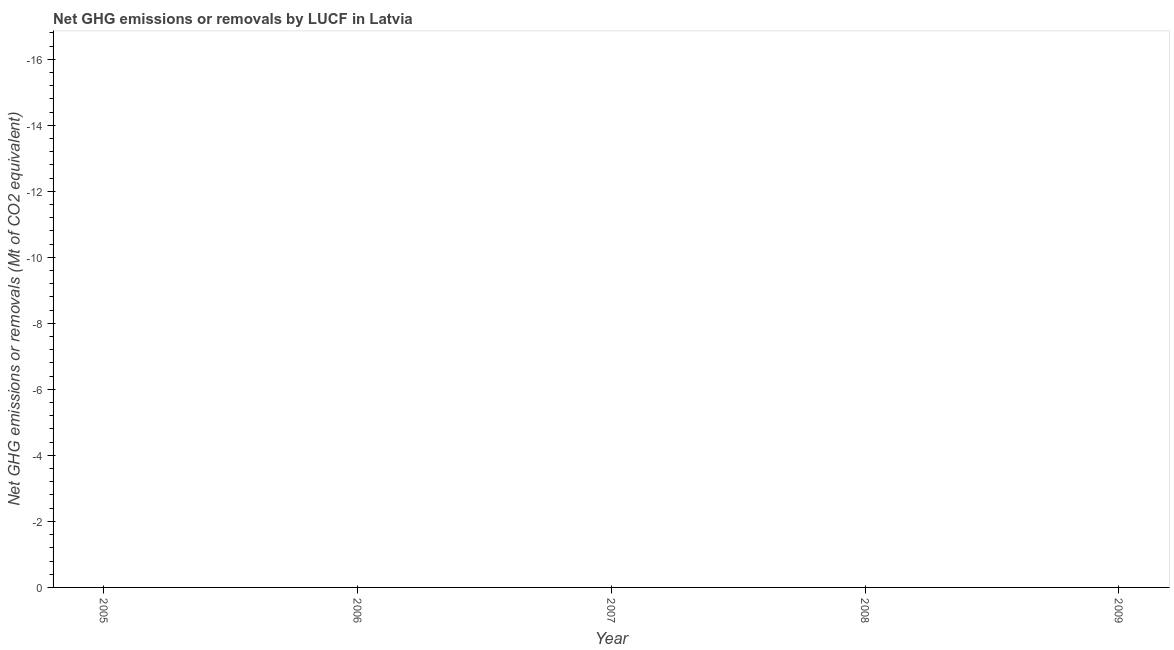Across all years, what is the minimum ghg net emissions or removals?
Ensure brevity in your answer.  0. What is the sum of the ghg net emissions or removals?
Make the answer very short. 0. Does the ghg net emissions or removals monotonically increase over the years?
Offer a terse response. No. How many dotlines are there?
Your answer should be compact. 0. How many years are there in the graph?
Your answer should be very brief. 5. Does the graph contain any zero values?
Offer a very short reply. Yes. What is the title of the graph?
Provide a short and direct response. Net GHG emissions or removals by LUCF in Latvia. What is the label or title of the X-axis?
Your answer should be very brief. Year. What is the label or title of the Y-axis?
Provide a short and direct response. Net GHG emissions or removals (Mt of CO2 equivalent). What is the Net GHG emissions or removals (Mt of CO2 equivalent) in 2005?
Your response must be concise. 0. What is the Net GHG emissions or removals (Mt of CO2 equivalent) in 2006?
Keep it short and to the point. 0. What is the Net GHG emissions or removals (Mt of CO2 equivalent) in 2007?
Keep it short and to the point. 0. What is the Net GHG emissions or removals (Mt of CO2 equivalent) in 2008?
Give a very brief answer. 0. What is the Net GHG emissions or removals (Mt of CO2 equivalent) in 2009?
Your answer should be very brief. 0. 